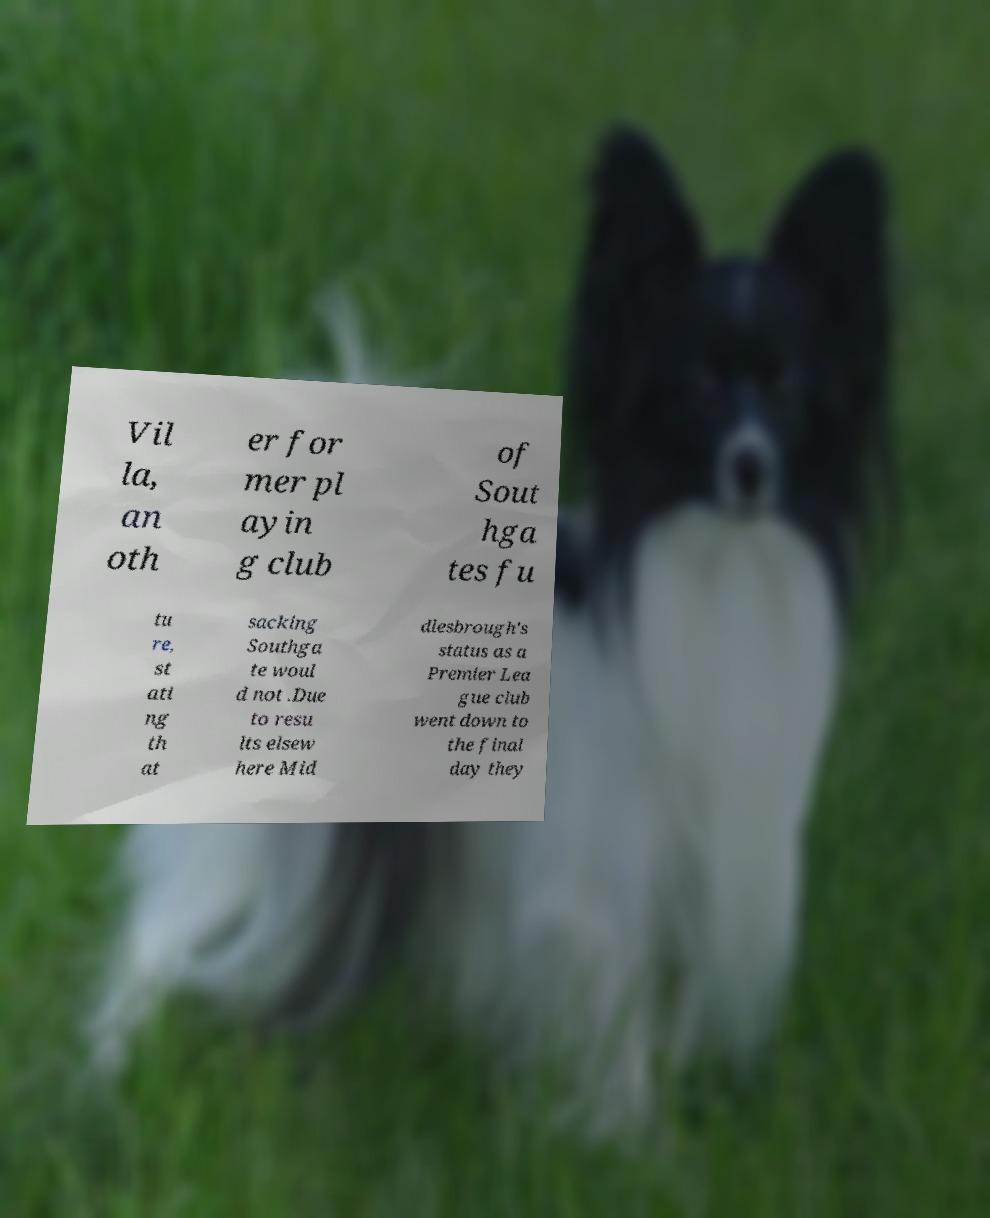Can you accurately transcribe the text from the provided image for me? Vil la, an oth er for mer pl ayin g club of Sout hga tes fu tu re, st ati ng th at sacking Southga te woul d not .Due to resu lts elsew here Mid dlesbrough's status as a Premier Lea gue club went down to the final day they 